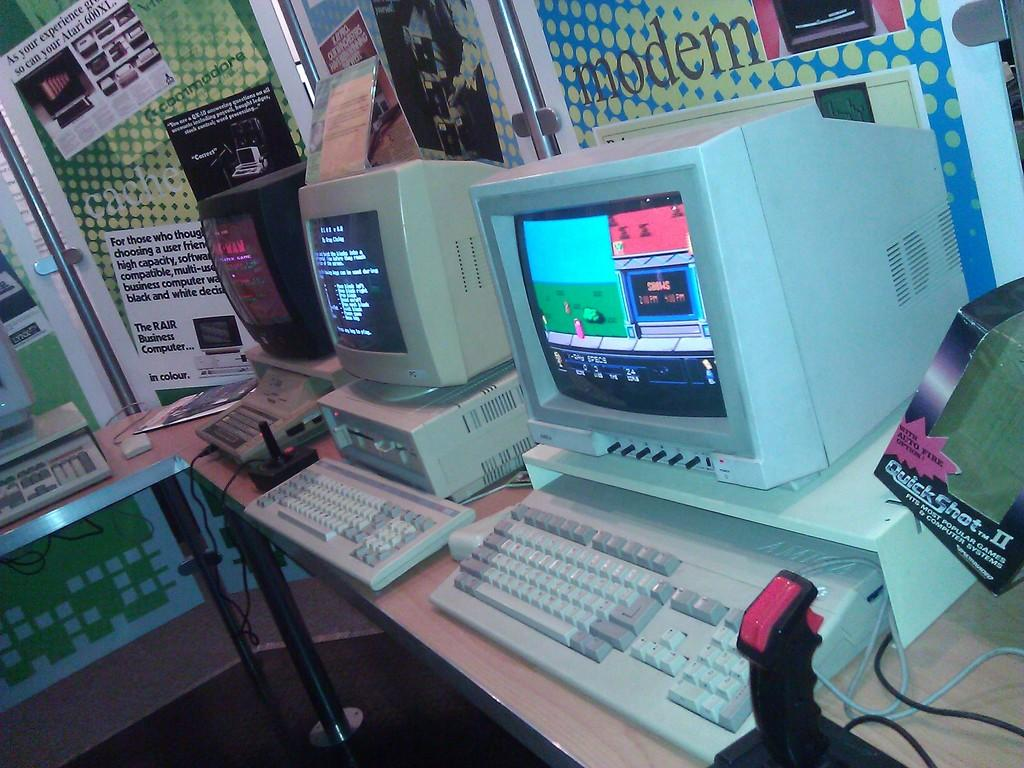<image>
Summarize the visual content of the image. a computer screen that says 'shows' on it in orange 